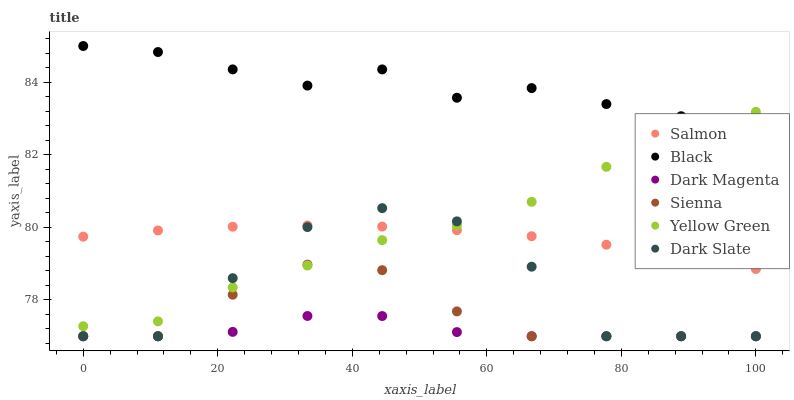Does Dark Magenta have the minimum area under the curve?
Answer yes or no. Yes. Does Black have the maximum area under the curve?
Answer yes or no. Yes. Does Salmon have the minimum area under the curve?
Answer yes or no. No. Does Salmon have the maximum area under the curve?
Answer yes or no. No. Is Salmon the smoothest?
Answer yes or no. Yes. Is Dark Slate the roughest?
Answer yes or no. Yes. Is Sienna the smoothest?
Answer yes or no. No. Is Sienna the roughest?
Answer yes or no. No. Does Dark Magenta have the lowest value?
Answer yes or no. Yes. Does Salmon have the lowest value?
Answer yes or no. No. Does Black have the highest value?
Answer yes or no. Yes. Does Salmon have the highest value?
Answer yes or no. No. Is Dark Magenta less than Black?
Answer yes or no. Yes. Is Black greater than Dark Slate?
Answer yes or no. Yes. Does Dark Slate intersect Dark Magenta?
Answer yes or no. Yes. Is Dark Slate less than Dark Magenta?
Answer yes or no. No. Is Dark Slate greater than Dark Magenta?
Answer yes or no. No. Does Dark Magenta intersect Black?
Answer yes or no. No. 